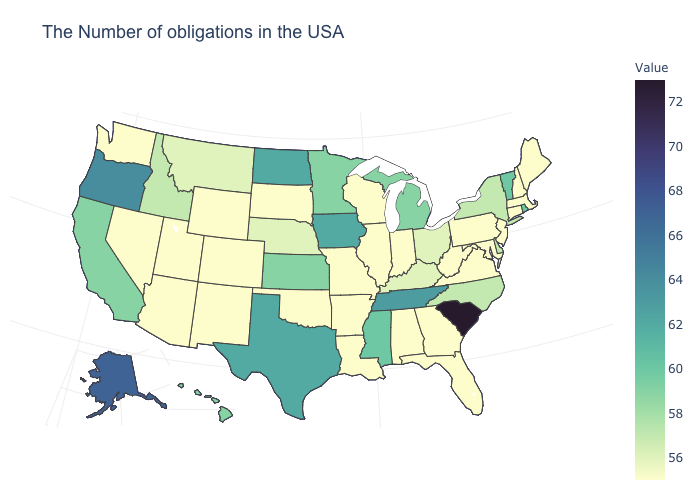Does Wisconsin have the lowest value in the MidWest?
Concise answer only. Yes. Is the legend a continuous bar?
Quick response, please. Yes. Which states have the highest value in the USA?
Answer briefly. South Carolina. Does South Carolina have the highest value in the South?
Write a very short answer. Yes. Which states have the lowest value in the Northeast?
Answer briefly. Maine, Massachusetts, New Hampshire, Connecticut, New Jersey, Pennsylvania. Which states have the highest value in the USA?
Concise answer only. South Carolina. Does New York have a lower value than Virginia?
Keep it brief. No. 